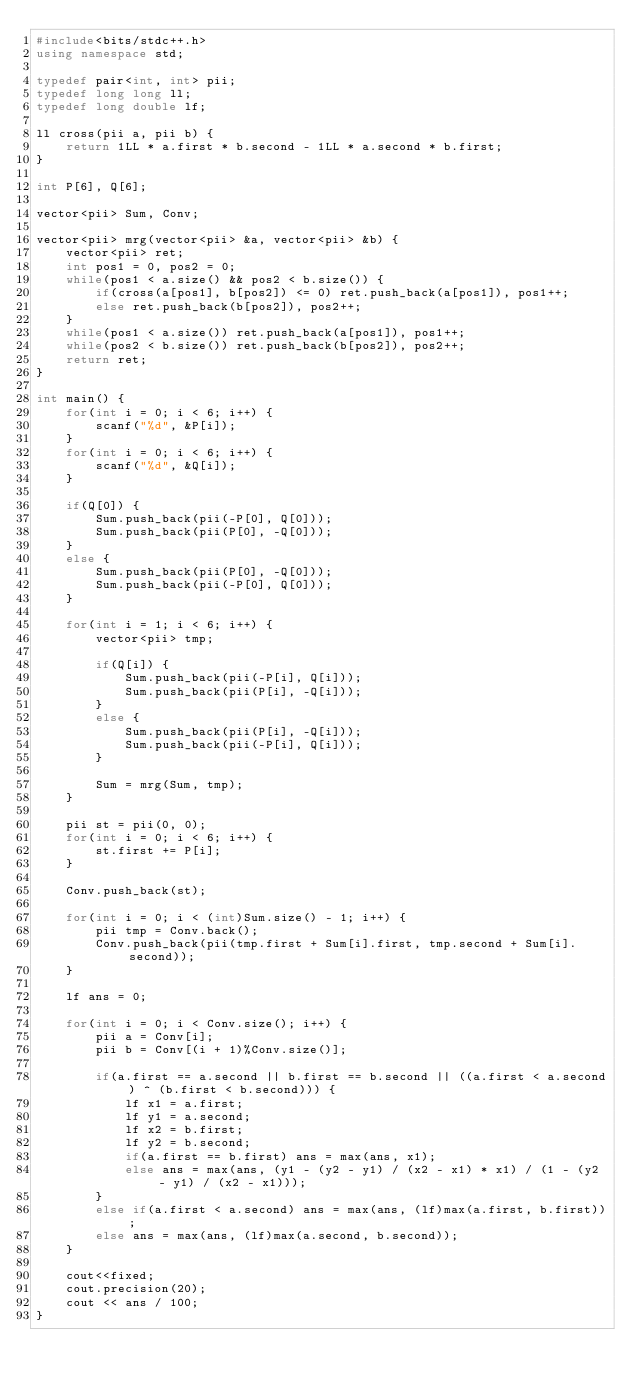<code> <loc_0><loc_0><loc_500><loc_500><_C++_>#include<bits/stdc++.h>
using namespace std;

typedef pair<int, int> pii;
typedef long long ll;
typedef long double lf;

ll cross(pii a, pii b) {
    return 1LL * a.first * b.second - 1LL * a.second * b.first;
}

int P[6], Q[6];

vector<pii> Sum, Conv;

vector<pii> mrg(vector<pii> &a, vector<pii> &b) {
    vector<pii> ret;
    int pos1 = 0, pos2 = 0;
    while(pos1 < a.size() && pos2 < b.size()) {
        if(cross(a[pos1], b[pos2]) <= 0) ret.push_back(a[pos1]), pos1++;
        else ret.push_back(b[pos2]), pos2++;
    }
    while(pos1 < a.size()) ret.push_back(a[pos1]), pos1++;
    while(pos2 < b.size()) ret.push_back(b[pos2]), pos2++;
    return ret;
}

int main() {
    for(int i = 0; i < 6; i++) {
        scanf("%d", &P[i]);
    }
    for(int i = 0; i < 6; i++) {
        scanf("%d", &Q[i]);
    }

    if(Q[0]) {
        Sum.push_back(pii(-P[0], Q[0]));
        Sum.push_back(pii(P[0], -Q[0]));
    }
    else {
        Sum.push_back(pii(P[0], -Q[0]));
        Sum.push_back(pii(-P[0], Q[0]));
    }

    for(int i = 1; i < 6; i++) {
        vector<pii> tmp;

        if(Q[i]) {
            Sum.push_back(pii(-P[i], Q[i]));
            Sum.push_back(pii(P[i], -Q[i]));
        }
        else {
            Sum.push_back(pii(P[i], -Q[i]));
            Sum.push_back(pii(-P[i], Q[i]));
        }
        
        Sum = mrg(Sum, tmp);
    }

    pii st = pii(0, 0);
    for(int i = 0; i < 6; i++) {
        st.first += P[i];
    }

    Conv.push_back(st);

    for(int i = 0; i < (int)Sum.size() - 1; i++) {
        pii tmp = Conv.back();
        Conv.push_back(pii(tmp.first + Sum[i].first, tmp.second + Sum[i].second));
    }

    lf ans = 0;

    for(int i = 0; i < Conv.size(); i++) {
        pii a = Conv[i];
        pii b = Conv[(i + 1)%Conv.size()];

        if(a.first == a.second || b.first == b.second || ((a.first < a.second) ^ (b.first < b.second))) {
            lf x1 = a.first;
            lf y1 = a.second;
            lf x2 = b.first;
            lf y2 = b.second;
            if(a.first == b.first) ans = max(ans, x1);
            else ans = max(ans, (y1 - (y2 - y1) / (x2 - x1) * x1) / (1 - (y2 - y1) / (x2 - x1)));
        }
        else if(a.first < a.second) ans = max(ans, (lf)max(a.first, b.first));
        else ans = max(ans, (lf)max(a.second, b.second));
    }

    cout<<fixed;
    cout.precision(20);
    cout << ans / 100;
}
</code> 